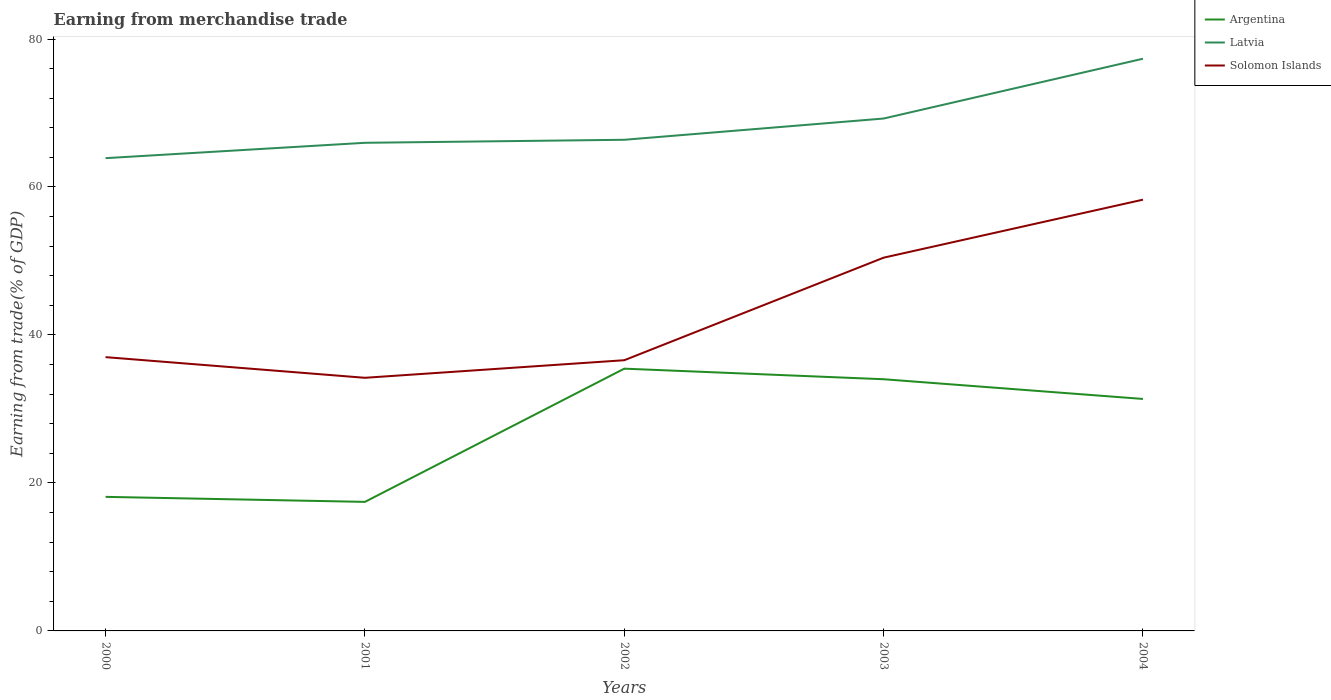Across all years, what is the maximum earnings from trade in Argentina?
Your answer should be compact. 17.44. In which year was the earnings from trade in Latvia maximum?
Offer a very short reply. 2000. What is the total earnings from trade in Latvia in the graph?
Make the answer very short. -8.08. What is the difference between the highest and the second highest earnings from trade in Latvia?
Your answer should be very brief. 13.44. Is the earnings from trade in Solomon Islands strictly greater than the earnings from trade in Latvia over the years?
Offer a very short reply. Yes. How many lines are there?
Make the answer very short. 3. Does the graph contain grids?
Offer a terse response. No. How are the legend labels stacked?
Make the answer very short. Vertical. What is the title of the graph?
Offer a terse response. Earning from merchandise trade. Does "Bosnia and Herzegovina" appear as one of the legend labels in the graph?
Your answer should be compact. No. What is the label or title of the X-axis?
Make the answer very short. Years. What is the label or title of the Y-axis?
Give a very brief answer. Earning from trade(% of GDP). What is the Earning from trade(% of GDP) of Argentina in 2000?
Your answer should be very brief. 18.12. What is the Earning from trade(% of GDP) in Latvia in 2000?
Provide a short and direct response. 63.9. What is the Earning from trade(% of GDP) in Solomon Islands in 2000?
Offer a very short reply. 37. What is the Earning from trade(% of GDP) of Argentina in 2001?
Provide a short and direct response. 17.44. What is the Earning from trade(% of GDP) of Latvia in 2001?
Make the answer very short. 65.97. What is the Earning from trade(% of GDP) of Solomon Islands in 2001?
Keep it short and to the point. 34.21. What is the Earning from trade(% of GDP) of Argentina in 2002?
Ensure brevity in your answer.  35.45. What is the Earning from trade(% of GDP) in Latvia in 2002?
Give a very brief answer. 66.38. What is the Earning from trade(% of GDP) in Solomon Islands in 2002?
Keep it short and to the point. 36.59. What is the Earning from trade(% of GDP) in Argentina in 2003?
Offer a very short reply. 34.02. What is the Earning from trade(% of GDP) in Latvia in 2003?
Keep it short and to the point. 69.25. What is the Earning from trade(% of GDP) in Solomon Islands in 2003?
Provide a short and direct response. 50.44. What is the Earning from trade(% of GDP) of Argentina in 2004?
Offer a very short reply. 31.35. What is the Earning from trade(% of GDP) of Latvia in 2004?
Provide a short and direct response. 77.33. What is the Earning from trade(% of GDP) of Solomon Islands in 2004?
Give a very brief answer. 58.29. Across all years, what is the maximum Earning from trade(% of GDP) in Argentina?
Make the answer very short. 35.45. Across all years, what is the maximum Earning from trade(% of GDP) in Latvia?
Your answer should be compact. 77.33. Across all years, what is the maximum Earning from trade(% of GDP) in Solomon Islands?
Your answer should be very brief. 58.29. Across all years, what is the minimum Earning from trade(% of GDP) of Argentina?
Your answer should be very brief. 17.44. Across all years, what is the minimum Earning from trade(% of GDP) in Latvia?
Make the answer very short. 63.9. Across all years, what is the minimum Earning from trade(% of GDP) in Solomon Islands?
Offer a very short reply. 34.21. What is the total Earning from trade(% of GDP) in Argentina in the graph?
Provide a short and direct response. 136.37. What is the total Earning from trade(% of GDP) of Latvia in the graph?
Provide a short and direct response. 342.83. What is the total Earning from trade(% of GDP) of Solomon Islands in the graph?
Give a very brief answer. 216.53. What is the difference between the Earning from trade(% of GDP) in Argentina in 2000 and that in 2001?
Provide a succinct answer. 0.68. What is the difference between the Earning from trade(% of GDP) of Latvia in 2000 and that in 2001?
Your response must be concise. -2.08. What is the difference between the Earning from trade(% of GDP) of Solomon Islands in 2000 and that in 2001?
Offer a terse response. 2.79. What is the difference between the Earning from trade(% of GDP) of Argentina in 2000 and that in 2002?
Offer a very short reply. -17.33. What is the difference between the Earning from trade(% of GDP) in Latvia in 2000 and that in 2002?
Offer a very short reply. -2.48. What is the difference between the Earning from trade(% of GDP) of Solomon Islands in 2000 and that in 2002?
Your answer should be compact. 0.42. What is the difference between the Earning from trade(% of GDP) of Argentina in 2000 and that in 2003?
Your response must be concise. -15.9. What is the difference between the Earning from trade(% of GDP) in Latvia in 2000 and that in 2003?
Your answer should be very brief. -5.36. What is the difference between the Earning from trade(% of GDP) of Solomon Islands in 2000 and that in 2003?
Make the answer very short. -13.44. What is the difference between the Earning from trade(% of GDP) of Argentina in 2000 and that in 2004?
Keep it short and to the point. -13.23. What is the difference between the Earning from trade(% of GDP) of Latvia in 2000 and that in 2004?
Make the answer very short. -13.44. What is the difference between the Earning from trade(% of GDP) in Solomon Islands in 2000 and that in 2004?
Make the answer very short. -21.28. What is the difference between the Earning from trade(% of GDP) of Argentina in 2001 and that in 2002?
Offer a terse response. -18.01. What is the difference between the Earning from trade(% of GDP) in Latvia in 2001 and that in 2002?
Offer a terse response. -0.41. What is the difference between the Earning from trade(% of GDP) of Solomon Islands in 2001 and that in 2002?
Offer a very short reply. -2.38. What is the difference between the Earning from trade(% of GDP) in Argentina in 2001 and that in 2003?
Your answer should be very brief. -16.58. What is the difference between the Earning from trade(% of GDP) in Latvia in 2001 and that in 2003?
Offer a terse response. -3.28. What is the difference between the Earning from trade(% of GDP) of Solomon Islands in 2001 and that in 2003?
Give a very brief answer. -16.23. What is the difference between the Earning from trade(% of GDP) in Argentina in 2001 and that in 2004?
Provide a succinct answer. -13.91. What is the difference between the Earning from trade(% of GDP) in Latvia in 2001 and that in 2004?
Your response must be concise. -11.36. What is the difference between the Earning from trade(% of GDP) in Solomon Islands in 2001 and that in 2004?
Ensure brevity in your answer.  -24.08. What is the difference between the Earning from trade(% of GDP) of Argentina in 2002 and that in 2003?
Provide a short and direct response. 1.43. What is the difference between the Earning from trade(% of GDP) of Latvia in 2002 and that in 2003?
Offer a very short reply. -2.87. What is the difference between the Earning from trade(% of GDP) of Solomon Islands in 2002 and that in 2003?
Your answer should be very brief. -13.86. What is the difference between the Earning from trade(% of GDP) of Argentina in 2002 and that in 2004?
Make the answer very short. 4.09. What is the difference between the Earning from trade(% of GDP) in Latvia in 2002 and that in 2004?
Your answer should be compact. -10.95. What is the difference between the Earning from trade(% of GDP) in Solomon Islands in 2002 and that in 2004?
Your answer should be very brief. -21.7. What is the difference between the Earning from trade(% of GDP) of Argentina in 2003 and that in 2004?
Make the answer very short. 2.66. What is the difference between the Earning from trade(% of GDP) of Latvia in 2003 and that in 2004?
Your answer should be very brief. -8.08. What is the difference between the Earning from trade(% of GDP) of Solomon Islands in 2003 and that in 2004?
Make the answer very short. -7.84. What is the difference between the Earning from trade(% of GDP) in Argentina in 2000 and the Earning from trade(% of GDP) in Latvia in 2001?
Your answer should be very brief. -47.85. What is the difference between the Earning from trade(% of GDP) in Argentina in 2000 and the Earning from trade(% of GDP) in Solomon Islands in 2001?
Make the answer very short. -16.09. What is the difference between the Earning from trade(% of GDP) of Latvia in 2000 and the Earning from trade(% of GDP) of Solomon Islands in 2001?
Provide a short and direct response. 29.69. What is the difference between the Earning from trade(% of GDP) of Argentina in 2000 and the Earning from trade(% of GDP) of Latvia in 2002?
Your response must be concise. -48.26. What is the difference between the Earning from trade(% of GDP) in Argentina in 2000 and the Earning from trade(% of GDP) in Solomon Islands in 2002?
Ensure brevity in your answer.  -18.47. What is the difference between the Earning from trade(% of GDP) in Latvia in 2000 and the Earning from trade(% of GDP) in Solomon Islands in 2002?
Offer a very short reply. 27.31. What is the difference between the Earning from trade(% of GDP) of Argentina in 2000 and the Earning from trade(% of GDP) of Latvia in 2003?
Give a very brief answer. -51.13. What is the difference between the Earning from trade(% of GDP) of Argentina in 2000 and the Earning from trade(% of GDP) of Solomon Islands in 2003?
Provide a succinct answer. -32.33. What is the difference between the Earning from trade(% of GDP) of Latvia in 2000 and the Earning from trade(% of GDP) of Solomon Islands in 2003?
Provide a succinct answer. 13.45. What is the difference between the Earning from trade(% of GDP) of Argentina in 2000 and the Earning from trade(% of GDP) of Latvia in 2004?
Make the answer very short. -59.21. What is the difference between the Earning from trade(% of GDP) of Argentina in 2000 and the Earning from trade(% of GDP) of Solomon Islands in 2004?
Ensure brevity in your answer.  -40.17. What is the difference between the Earning from trade(% of GDP) in Latvia in 2000 and the Earning from trade(% of GDP) in Solomon Islands in 2004?
Provide a succinct answer. 5.61. What is the difference between the Earning from trade(% of GDP) of Argentina in 2001 and the Earning from trade(% of GDP) of Latvia in 2002?
Provide a succinct answer. -48.94. What is the difference between the Earning from trade(% of GDP) in Argentina in 2001 and the Earning from trade(% of GDP) in Solomon Islands in 2002?
Keep it short and to the point. -19.14. What is the difference between the Earning from trade(% of GDP) of Latvia in 2001 and the Earning from trade(% of GDP) of Solomon Islands in 2002?
Provide a short and direct response. 29.39. What is the difference between the Earning from trade(% of GDP) of Argentina in 2001 and the Earning from trade(% of GDP) of Latvia in 2003?
Provide a short and direct response. -51.81. What is the difference between the Earning from trade(% of GDP) of Argentina in 2001 and the Earning from trade(% of GDP) of Solomon Islands in 2003?
Your response must be concise. -33. What is the difference between the Earning from trade(% of GDP) in Latvia in 2001 and the Earning from trade(% of GDP) in Solomon Islands in 2003?
Your response must be concise. 15.53. What is the difference between the Earning from trade(% of GDP) in Argentina in 2001 and the Earning from trade(% of GDP) in Latvia in 2004?
Your answer should be very brief. -59.89. What is the difference between the Earning from trade(% of GDP) of Argentina in 2001 and the Earning from trade(% of GDP) of Solomon Islands in 2004?
Your response must be concise. -40.84. What is the difference between the Earning from trade(% of GDP) in Latvia in 2001 and the Earning from trade(% of GDP) in Solomon Islands in 2004?
Provide a short and direct response. 7.69. What is the difference between the Earning from trade(% of GDP) in Argentina in 2002 and the Earning from trade(% of GDP) in Latvia in 2003?
Make the answer very short. -33.81. What is the difference between the Earning from trade(% of GDP) of Argentina in 2002 and the Earning from trade(% of GDP) of Solomon Islands in 2003?
Give a very brief answer. -15. What is the difference between the Earning from trade(% of GDP) in Latvia in 2002 and the Earning from trade(% of GDP) in Solomon Islands in 2003?
Your response must be concise. 15.93. What is the difference between the Earning from trade(% of GDP) in Argentina in 2002 and the Earning from trade(% of GDP) in Latvia in 2004?
Ensure brevity in your answer.  -41.89. What is the difference between the Earning from trade(% of GDP) in Argentina in 2002 and the Earning from trade(% of GDP) in Solomon Islands in 2004?
Provide a short and direct response. -22.84. What is the difference between the Earning from trade(% of GDP) of Latvia in 2002 and the Earning from trade(% of GDP) of Solomon Islands in 2004?
Your answer should be very brief. 8.09. What is the difference between the Earning from trade(% of GDP) of Argentina in 2003 and the Earning from trade(% of GDP) of Latvia in 2004?
Your response must be concise. -43.32. What is the difference between the Earning from trade(% of GDP) in Argentina in 2003 and the Earning from trade(% of GDP) in Solomon Islands in 2004?
Offer a very short reply. -24.27. What is the difference between the Earning from trade(% of GDP) in Latvia in 2003 and the Earning from trade(% of GDP) in Solomon Islands in 2004?
Your answer should be very brief. 10.97. What is the average Earning from trade(% of GDP) of Argentina per year?
Make the answer very short. 27.27. What is the average Earning from trade(% of GDP) of Latvia per year?
Your answer should be very brief. 68.57. What is the average Earning from trade(% of GDP) in Solomon Islands per year?
Make the answer very short. 43.31. In the year 2000, what is the difference between the Earning from trade(% of GDP) in Argentina and Earning from trade(% of GDP) in Latvia?
Give a very brief answer. -45.78. In the year 2000, what is the difference between the Earning from trade(% of GDP) of Argentina and Earning from trade(% of GDP) of Solomon Islands?
Your response must be concise. -18.88. In the year 2000, what is the difference between the Earning from trade(% of GDP) of Latvia and Earning from trade(% of GDP) of Solomon Islands?
Ensure brevity in your answer.  26.89. In the year 2001, what is the difference between the Earning from trade(% of GDP) of Argentina and Earning from trade(% of GDP) of Latvia?
Your answer should be compact. -48.53. In the year 2001, what is the difference between the Earning from trade(% of GDP) of Argentina and Earning from trade(% of GDP) of Solomon Islands?
Keep it short and to the point. -16.77. In the year 2001, what is the difference between the Earning from trade(% of GDP) in Latvia and Earning from trade(% of GDP) in Solomon Islands?
Keep it short and to the point. 31.76. In the year 2002, what is the difference between the Earning from trade(% of GDP) in Argentina and Earning from trade(% of GDP) in Latvia?
Give a very brief answer. -30.93. In the year 2002, what is the difference between the Earning from trade(% of GDP) of Argentina and Earning from trade(% of GDP) of Solomon Islands?
Provide a short and direct response. -1.14. In the year 2002, what is the difference between the Earning from trade(% of GDP) of Latvia and Earning from trade(% of GDP) of Solomon Islands?
Give a very brief answer. 29.79. In the year 2003, what is the difference between the Earning from trade(% of GDP) of Argentina and Earning from trade(% of GDP) of Latvia?
Your response must be concise. -35.24. In the year 2003, what is the difference between the Earning from trade(% of GDP) in Argentina and Earning from trade(% of GDP) in Solomon Islands?
Give a very brief answer. -16.43. In the year 2003, what is the difference between the Earning from trade(% of GDP) in Latvia and Earning from trade(% of GDP) in Solomon Islands?
Provide a short and direct response. 18.81. In the year 2004, what is the difference between the Earning from trade(% of GDP) of Argentina and Earning from trade(% of GDP) of Latvia?
Give a very brief answer. -45.98. In the year 2004, what is the difference between the Earning from trade(% of GDP) of Argentina and Earning from trade(% of GDP) of Solomon Islands?
Ensure brevity in your answer.  -26.93. In the year 2004, what is the difference between the Earning from trade(% of GDP) of Latvia and Earning from trade(% of GDP) of Solomon Islands?
Make the answer very short. 19.05. What is the ratio of the Earning from trade(% of GDP) of Argentina in 2000 to that in 2001?
Provide a short and direct response. 1.04. What is the ratio of the Earning from trade(% of GDP) of Latvia in 2000 to that in 2001?
Your answer should be compact. 0.97. What is the ratio of the Earning from trade(% of GDP) in Solomon Islands in 2000 to that in 2001?
Make the answer very short. 1.08. What is the ratio of the Earning from trade(% of GDP) in Argentina in 2000 to that in 2002?
Make the answer very short. 0.51. What is the ratio of the Earning from trade(% of GDP) in Latvia in 2000 to that in 2002?
Your response must be concise. 0.96. What is the ratio of the Earning from trade(% of GDP) of Solomon Islands in 2000 to that in 2002?
Provide a succinct answer. 1.01. What is the ratio of the Earning from trade(% of GDP) of Argentina in 2000 to that in 2003?
Make the answer very short. 0.53. What is the ratio of the Earning from trade(% of GDP) in Latvia in 2000 to that in 2003?
Your answer should be compact. 0.92. What is the ratio of the Earning from trade(% of GDP) of Solomon Islands in 2000 to that in 2003?
Make the answer very short. 0.73. What is the ratio of the Earning from trade(% of GDP) in Argentina in 2000 to that in 2004?
Offer a terse response. 0.58. What is the ratio of the Earning from trade(% of GDP) of Latvia in 2000 to that in 2004?
Provide a succinct answer. 0.83. What is the ratio of the Earning from trade(% of GDP) of Solomon Islands in 2000 to that in 2004?
Give a very brief answer. 0.63. What is the ratio of the Earning from trade(% of GDP) in Argentina in 2001 to that in 2002?
Your answer should be very brief. 0.49. What is the ratio of the Earning from trade(% of GDP) in Latvia in 2001 to that in 2002?
Provide a short and direct response. 0.99. What is the ratio of the Earning from trade(% of GDP) of Solomon Islands in 2001 to that in 2002?
Your response must be concise. 0.94. What is the ratio of the Earning from trade(% of GDP) in Argentina in 2001 to that in 2003?
Make the answer very short. 0.51. What is the ratio of the Earning from trade(% of GDP) of Latvia in 2001 to that in 2003?
Offer a very short reply. 0.95. What is the ratio of the Earning from trade(% of GDP) of Solomon Islands in 2001 to that in 2003?
Offer a very short reply. 0.68. What is the ratio of the Earning from trade(% of GDP) of Argentina in 2001 to that in 2004?
Your response must be concise. 0.56. What is the ratio of the Earning from trade(% of GDP) of Latvia in 2001 to that in 2004?
Provide a succinct answer. 0.85. What is the ratio of the Earning from trade(% of GDP) in Solomon Islands in 2001 to that in 2004?
Your answer should be compact. 0.59. What is the ratio of the Earning from trade(% of GDP) in Argentina in 2002 to that in 2003?
Your answer should be very brief. 1.04. What is the ratio of the Earning from trade(% of GDP) in Latvia in 2002 to that in 2003?
Your response must be concise. 0.96. What is the ratio of the Earning from trade(% of GDP) of Solomon Islands in 2002 to that in 2003?
Make the answer very short. 0.73. What is the ratio of the Earning from trade(% of GDP) in Argentina in 2002 to that in 2004?
Make the answer very short. 1.13. What is the ratio of the Earning from trade(% of GDP) in Latvia in 2002 to that in 2004?
Make the answer very short. 0.86. What is the ratio of the Earning from trade(% of GDP) in Solomon Islands in 2002 to that in 2004?
Your answer should be compact. 0.63. What is the ratio of the Earning from trade(% of GDP) in Argentina in 2003 to that in 2004?
Your answer should be compact. 1.08. What is the ratio of the Earning from trade(% of GDP) in Latvia in 2003 to that in 2004?
Keep it short and to the point. 0.9. What is the ratio of the Earning from trade(% of GDP) in Solomon Islands in 2003 to that in 2004?
Offer a terse response. 0.87. What is the difference between the highest and the second highest Earning from trade(% of GDP) in Argentina?
Your response must be concise. 1.43. What is the difference between the highest and the second highest Earning from trade(% of GDP) in Latvia?
Offer a terse response. 8.08. What is the difference between the highest and the second highest Earning from trade(% of GDP) of Solomon Islands?
Provide a succinct answer. 7.84. What is the difference between the highest and the lowest Earning from trade(% of GDP) in Argentina?
Ensure brevity in your answer.  18.01. What is the difference between the highest and the lowest Earning from trade(% of GDP) of Latvia?
Your response must be concise. 13.44. What is the difference between the highest and the lowest Earning from trade(% of GDP) of Solomon Islands?
Offer a very short reply. 24.08. 